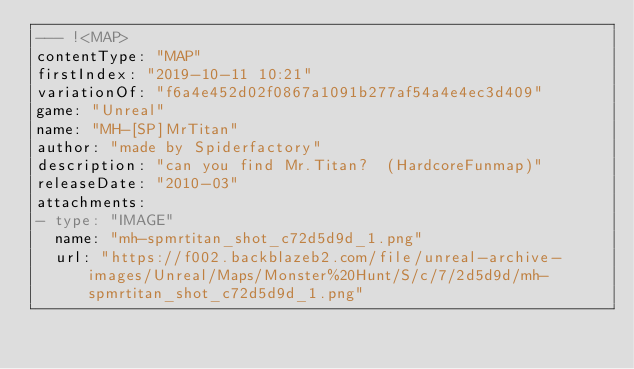<code> <loc_0><loc_0><loc_500><loc_500><_YAML_>--- !<MAP>
contentType: "MAP"
firstIndex: "2019-10-11 10:21"
variationOf: "f6a4e452d02f0867a1091b277af54a4e4ec3d409"
game: "Unreal"
name: "MH-[SP]MrTitan"
author: "made by Spiderfactory"
description: "can you find Mr.Titan?  (HardcoreFunmap)"
releaseDate: "2010-03"
attachments:
- type: "IMAGE"
  name: "mh-spmrtitan_shot_c72d5d9d_1.png"
  url: "https://f002.backblazeb2.com/file/unreal-archive-images/Unreal/Maps/Monster%20Hunt/S/c/7/2d5d9d/mh-spmrtitan_shot_c72d5d9d_1.png"</code> 